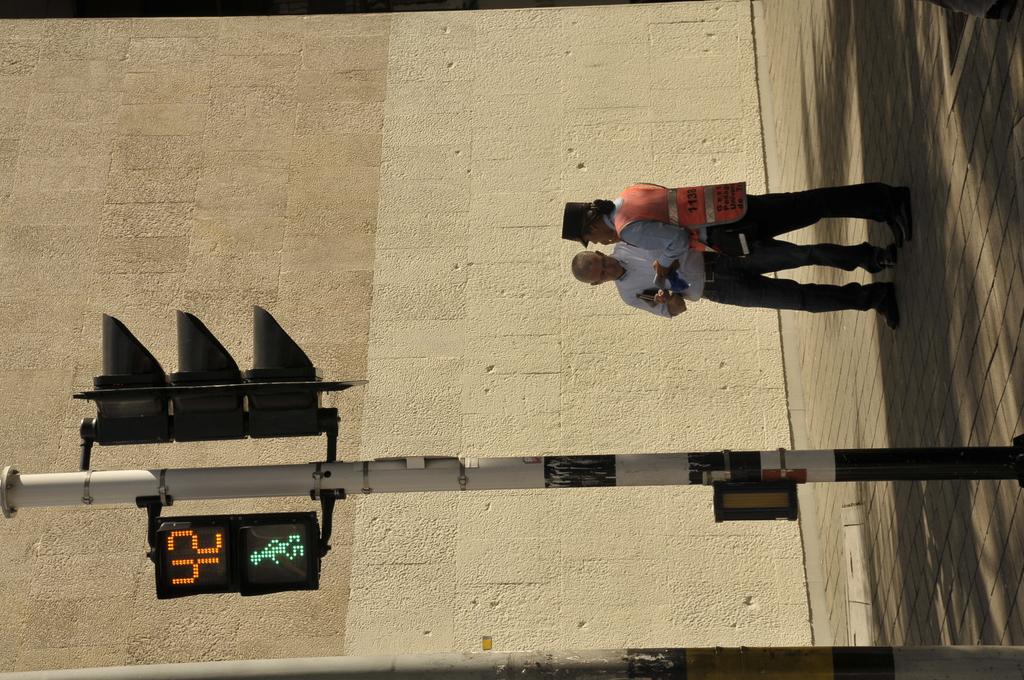How much time is left?
Keep it short and to the point. 42. 